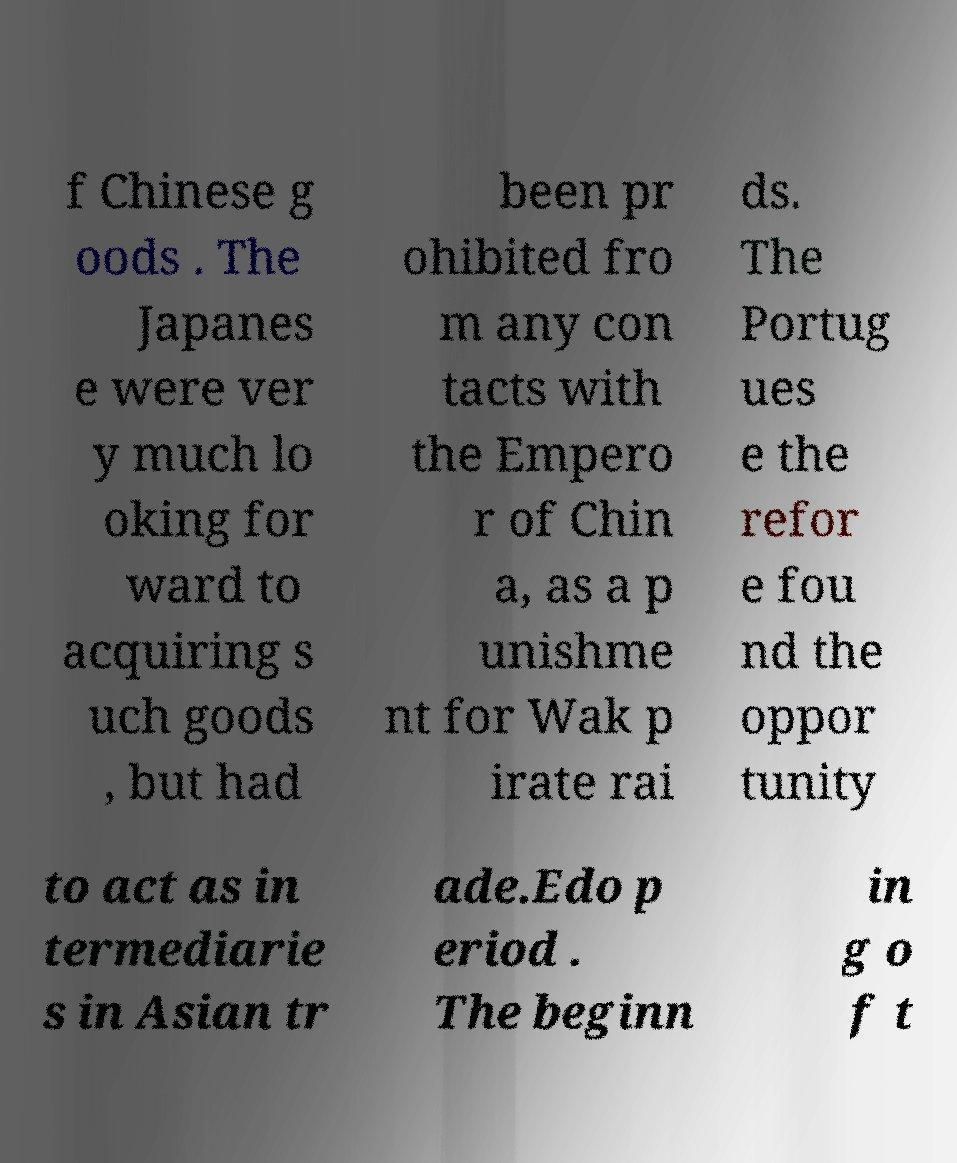For documentation purposes, I need the text within this image transcribed. Could you provide that? f Chinese g oods . The Japanes e were ver y much lo oking for ward to acquiring s uch goods , but had been pr ohibited fro m any con tacts with the Empero r of Chin a, as a p unishme nt for Wak p irate rai ds. The Portug ues e the refor e fou nd the oppor tunity to act as in termediarie s in Asian tr ade.Edo p eriod . The beginn in g o f t 